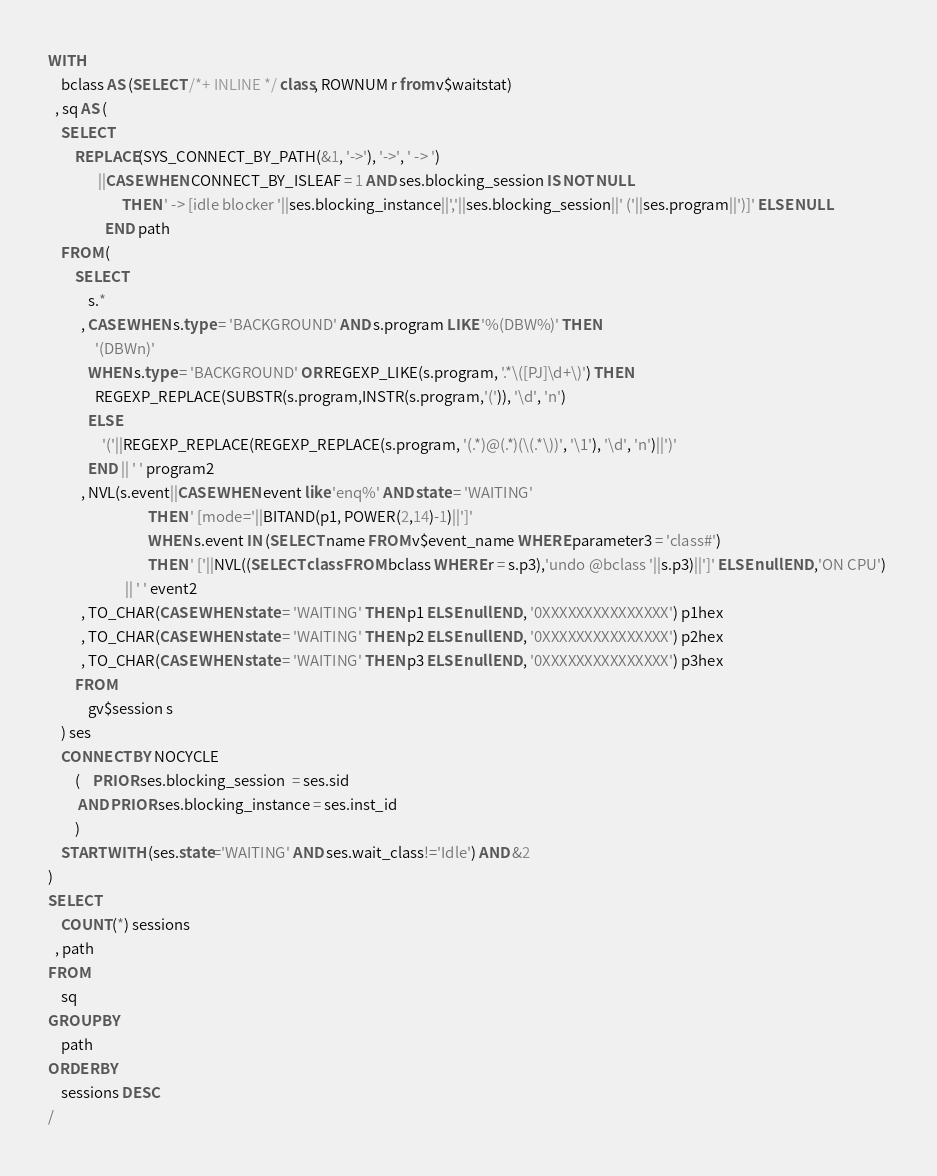<code> <loc_0><loc_0><loc_500><loc_500><_SQL_>WITH 
    bclass AS (SELECT /*+ INLINE */ class, ROWNUM r from v$waitstat)
  , sq AS (
    SELECT 
        REPLACE(SYS_CONNECT_BY_PATH(&1, '->'), '->', ' -> ')
               ||CASE WHEN CONNECT_BY_ISLEAF = 1 AND ses.blocking_session IS NOT NULL 
                      THEN ' -> [idle blocker '||ses.blocking_instance||','||ses.blocking_session||' ('||ses.program||')]' ELSE NULL   
                 END path
    FROM (
        SELECT
            s.*
          , CASE WHEN s.type = 'BACKGROUND' AND s.program LIKE '%(DBW%)' THEN
              '(DBWn)'
            WHEN s.type = 'BACKGROUND' OR REGEXP_LIKE(s.program, '.*\([PJ]\d+\)') THEN
              REGEXP_REPLACE(SUBSTR(s.program,INSTR(s.program,'(')), '\d', 'n')
            ELSE
                '('||REGEXP_REPLACE(REGEXP_REPLACE(s.program, '(.*)@(.*)(\(.*\))', '\1'), '\d', 'n')||')'
            END || ' ' program2
          , NVL(s.event||CASE WHEN event like 'enq%' AND state = 'WAITING'
                              THEN ' [mode='||BITAND(p1, POWER(2,14)-1)||']'
                              WHEN s.event IN (SELECT name FROM v$event_name WHERE parameter3 = 'class#')
                              THEN ' ['||NVL((SELECT class FROM bclass WHERE r = s.p3),'undo @bclass '||s.p3)||']' ELSE null END,'ON CPU') 
                       || ' ' event2
          , TO_CHAR(CASE WHEN state = 'WAITING' THEN p1 ELSE null END, '0XXXXXXXXXXXXXXX') p1hex
          , TO_CHAR(CASE WHEN state = 'WAITING' THEN p2 ELSE null END, '0XXXXXXXXXXXXXXX') p2hex
          , TO_CHAR(CASE WHEN state = 'WAITING' THEN p3 ELSE null END, '0XXXXXXXXXXXXXXX') p3hex
        FROM
            gv$session s
    ) ses
    CONNECT BY NOCYCLE
        (    PRIOR ses.blocking_session  = ses.sid
         AND PRIOR ses.blocking_instance = ses.inst_id
        )
    START WITH (ses.state='WAITING' AND ses.wait_class!='Idle') AND &2
)
SELECT
    COUNT(*) sessions
  , path
FROM
    sq
GROUP BY
    path
ORDER BY
    sessions DESC
/
</code> 